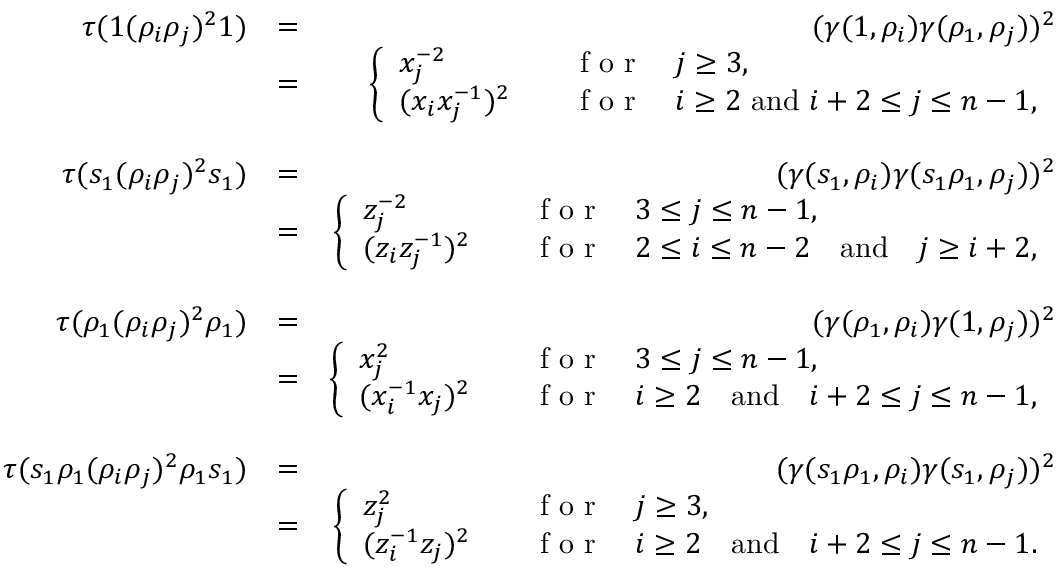Convert formula to latex. <formula><loc_0><loc_0><loc_500><loc_500>\begin{array} { r l r } { \tau ( 1 ( \rho _ { i } \rho _ { j } ) ^ { 2 } 1 ) } & { = } & { ( \gamma ( 1 , \rho _ { i } ) \gamma ( \rho _ { 1 } , \rho _ { j } ) ) ^ { 2 } } \\ & { = } & { \left \{ \begin{array} { l l } { x _ { j } ^ { - 2 } } & { \quad f o r \quad j \geq 3 , } \\ { ( x _ { i } x _ { j } ^ { - 1 } ) ^ { 2 } } & { \quad f o r \quad i \geq 2 a n d i + 2 \leq j \leq n - 1 , } \end{array} } \\ & \\ { \tau ( s _ { 1 } ( \rho _ { i } \rho _ { j } ) ^ { 2 } s _ { 1 } ) } & { = } & { ( \gamma ( s _ { 1 } , \rho _ { i } ) \gamma ( s _ { 1 } \rho _ { 1 } , \rho _ { j } ) ) ^ { 2 } } \\ & { = } & { \left \{ \begin{array} { l l } { z _ { j } ^ { - 2 } } & { \quad f o r \quad 3 \leq j \leq n - 1 , } \\ { ( z _ { i } z _ { j } ^ { - 1 } ) ^ { 2 } } & { \quad f o r \quad 2 \leq i \leq n - 2 \quad a n d \quad j \geq i + 2 , } \end{array} } \\ & \\ { \tau ( \rho _ { 1 } ( \rho _ { i } \rho _ { j } ) ^ { 2 } \rho _ { 1 } ) } & { = } & { ( \gamma ( \rho _ { 1 } , \rho _ { i } ) \gamma ( 1 , \rho _ { j } ) ) ^ { 2 } } \\ & { = } & { \left \{ \begin{array} { l l } { x _ { j } ^ { 2 } } & { \quad f o r \quad 3 \leq j \leq n - 1 , } \\ { ( x _ { i } ^ { - 1 } x _ { j } ) ^ { 2 } } & { \quad f o r \quad i \geq 2 \quad a n d \quad i + 2 \leq j \leq n - 1 , } \end{array} } \\ & \\ { \tau ( s _ { 1 } \rho _ { 1 } ( \rho _ { i } \rho _ { j } ) ^ { 2 } \rho _ { 1 } s _ { 1 } ) } & { = } & { ( \gamma ( s _ { 1 } \rho _ { 1 } , \rho _ { i } ) \gamma ( s _ { 1 } , \rho _ { j } ) ) ^ { 2 } } \\ & { = } & { \left \{ \begin{array} { l l } { z _ { j } ^ { 2 } } & { \quad f o r \quad j \geq 3 , } \\ { ( z _ { i } ^ { - 1 } z _ { j } ) ^ { 2 } } & { \quad f o r \quad i \geq 2 \quad a n d \quad i + 2 \leq j \leq n - 1 . } \end{array} } \end{array}</formula> 